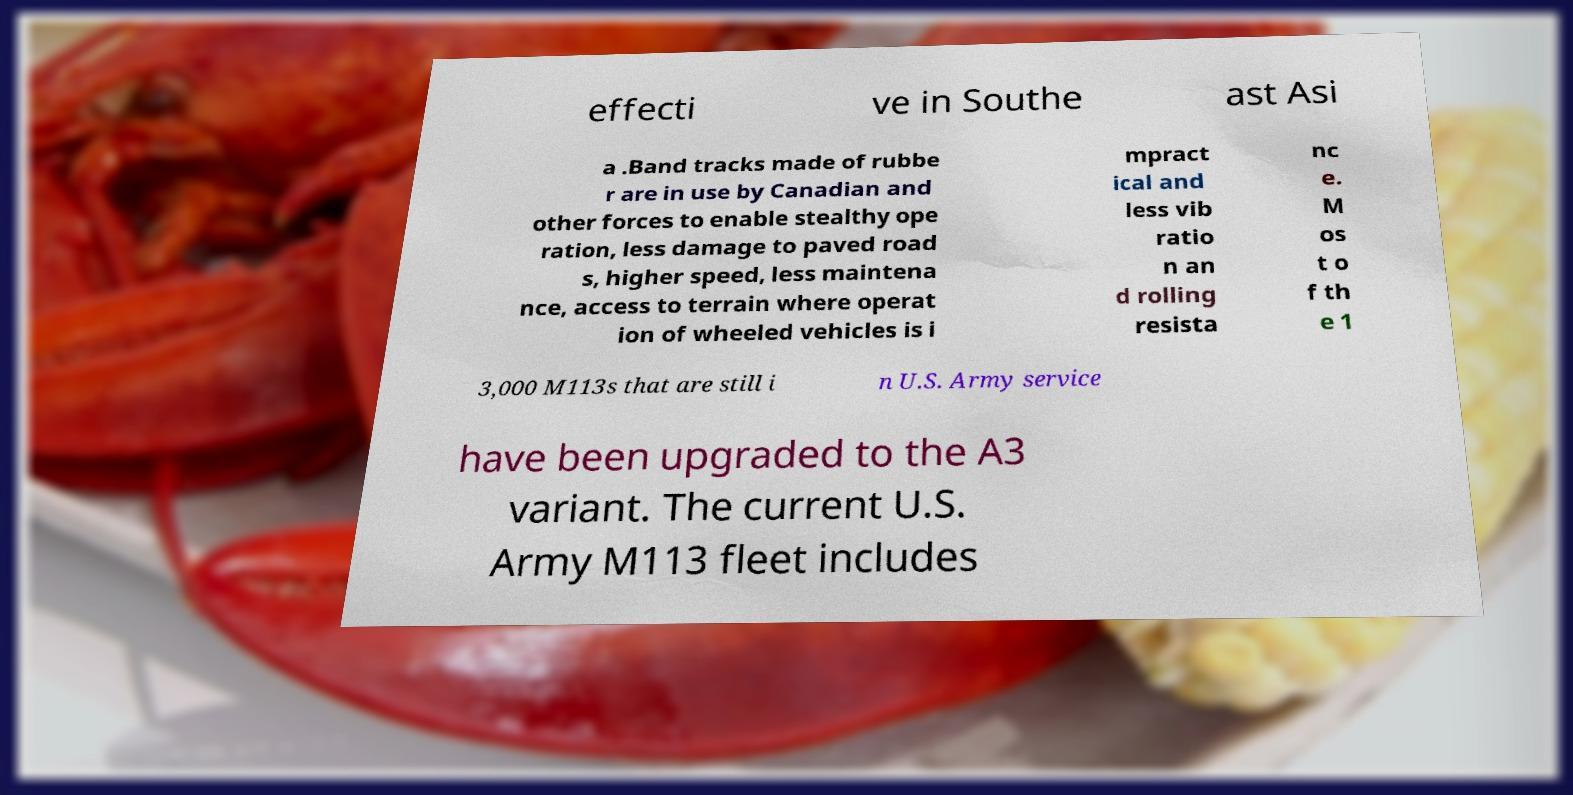Could you extract and type out the text from this image? effecti ve in Southe ast Asi a .Band tracks made of rubbe r are in use by Canadian and other forces to enable stealthy ope ration, less damage to paved road s, higher speed, less maintena nce, access to terrain where operat ion of wheeled vehicles is i mpract ical and less vib ratio n an d rolling resista nc e. M os t o f th e 1 3,000 M113s that are still i n U.S. Army service have been upgraded to the A3 variant. The current U.S. Army M113 fleet includes 